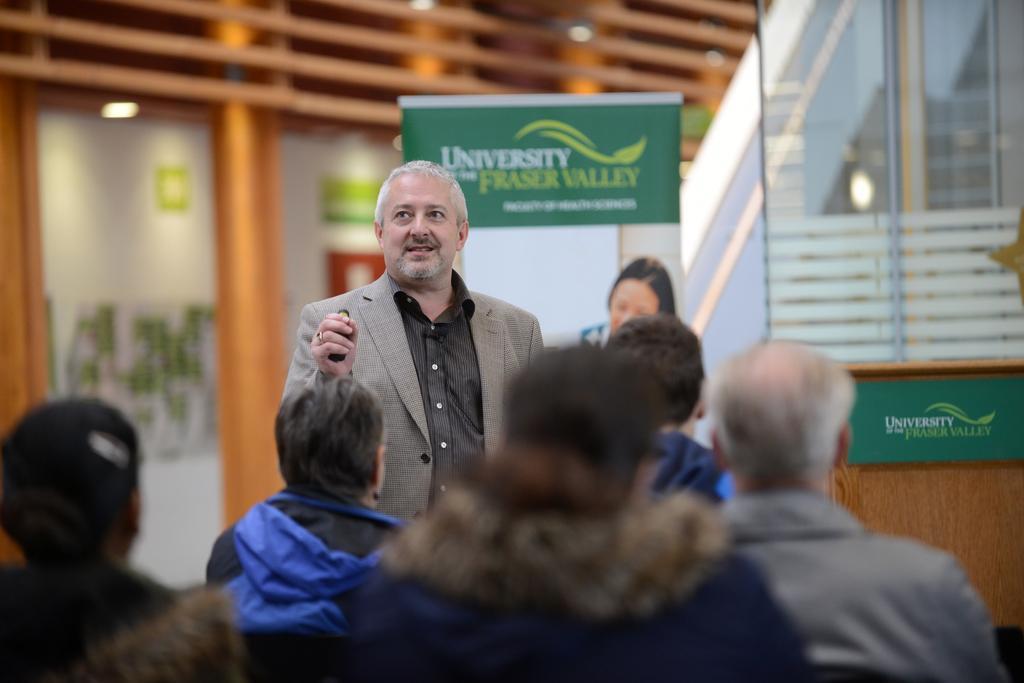Can you describe this image briefly? In this picture few people sitting and there is a man standing and holding an object. In the background of the image it is blurry and we can see banner, board, glass and lights. 